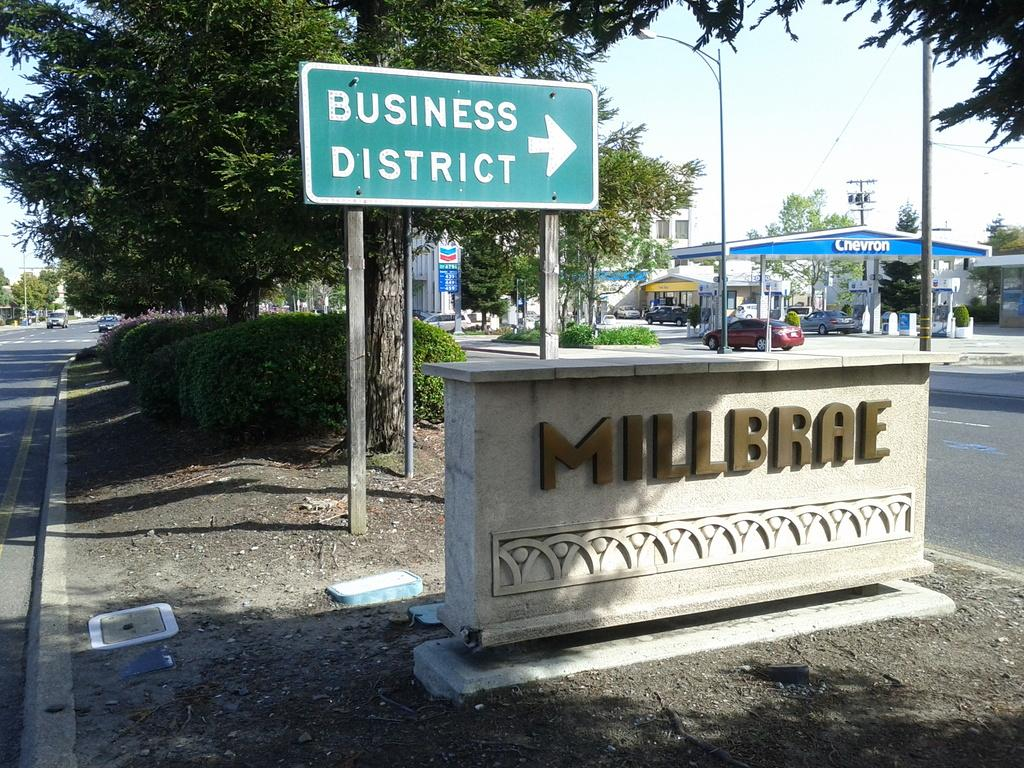What is present on the left side of the image? There is a sign board in the image. What can be found on the right side of the image? There is a petrol bunk at the right side of the image. What type of vehicles can be seen on the road in the image? Cars are visible on the road. What can be seen in the background of the image? There are trees in the background of the image. Where is the goose sitting in the image? There is no goose present in the image. What color is the knee of the person driving the car in the image? There are no people visible in the image, so it is impossible to determine the color of anyone's knee. 